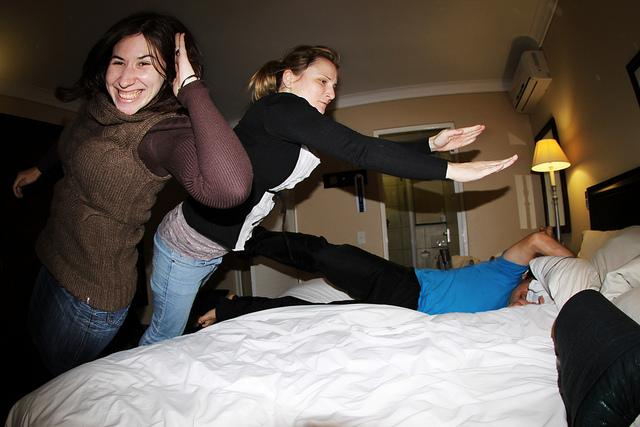It is time to hit the? Please explain your reasoning. hay. These people are jumping into or already landed on their bed. hitting the hay is a phrase that means going to bed. 